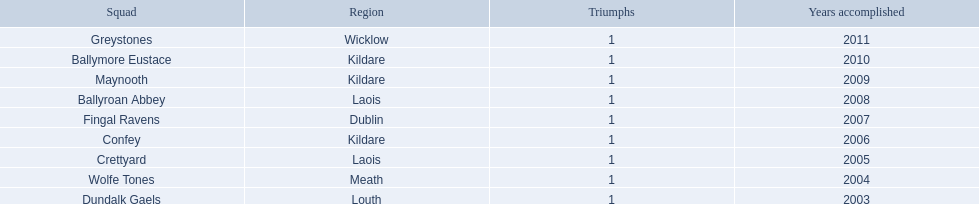What county is ballymore eustace from? Kildare. Besides convey, which other team is from the same county? Maynooth. 